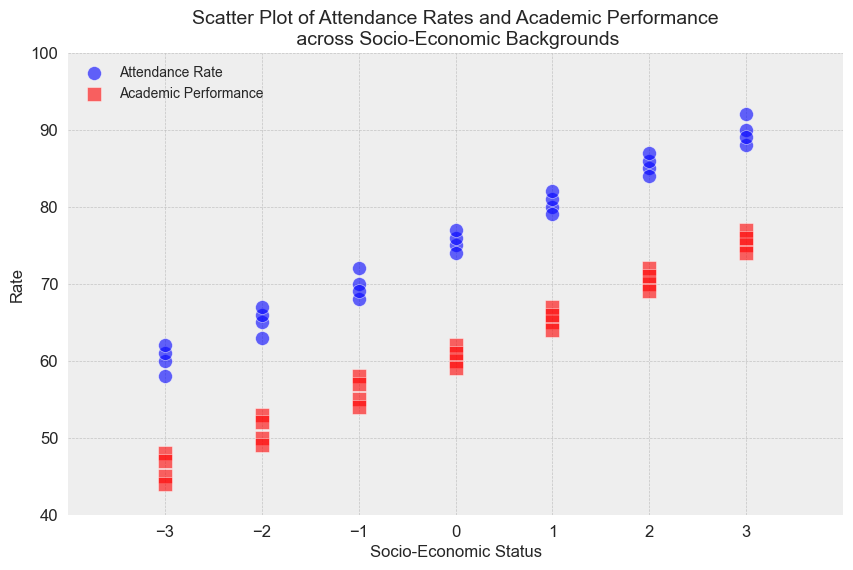How does attendance rate and academic performance change with socio-economic status? To understand the change, observe that as the socio-economic status moves from -3 to 3, both attendance rates and academic performances increase. For instance, at -3, the attendance rates are around 60 and academic performances are about 45, whereas at 3, these numbers increase to about 90 and 75 respectively.
Answer: Both increase Which socio-economic status has the lowest attendance rate reflected in the plot? To identify the lowest attendance rate, look for the lowest point on the vertical (attendance rate) axis. The lowest attendance rate observed is around 58 at the socio-economic status of -3.
Answer: -3 What is the difference in academic performance between the highest and lowest socio-economic status groups? To find the difference, subtract the academic performance of the lowest socio-economic status (-3, which is around 44 to 48) from the academic performance of the highest socio-economic status (3, which is around 74 to 77). One distinct pair shows 74 - 44 = 30.
Answer: 30 Is there a stronger visual pattern in the increase of attendance rates or academic performance as socio-economic status improves? Upon examining the scatter plot, the increase in attendance rates appears to be slightly more uniform and stronger as the socio-economic status improves compared to academic performance.
Answer: Attendance rates Among all the socio-economic statuses, which one exhibits the smallest range in academic performance? To find the smallest range, check the vertical spread of red squares at each socio-economic status value. The socio-economic status of 0 shows a relatively small range in academic performance, approximately 59 to 62, giving a range of 3.
Answer: 0 How does academic performance correlate with attendance rates when visualizing the data points? Observe the color-coded data points; the red squares are generally grouped at higher points of the blue circles, suggesting that higher attendance rates tend to be associated with higher academic performances.
Answer: Positively correlated What is the range of attendance rates for the socio-economic status -2? Look at the blue circles corresponding to the socio-economic status -2. The attendance rates range from 63 to 67, giving a range of 4.
Answer: 4 What can you infer from the clusters in the visual representation for socio-economic status 2? The clusters show blue circles (attendance rates) ranging from 84 to 87 and red squares (academic performances) ranging from 69 to 72. This represents a tight cluster indicating a consistent relation in that socio-economic status group.
Answer: Consistency in both rates 